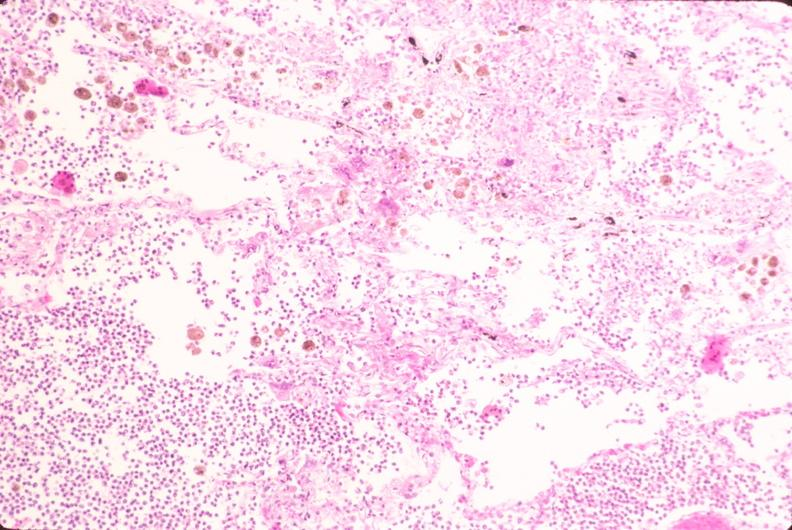what does this image show?
Answer the question using a single word or phrase. Lung 